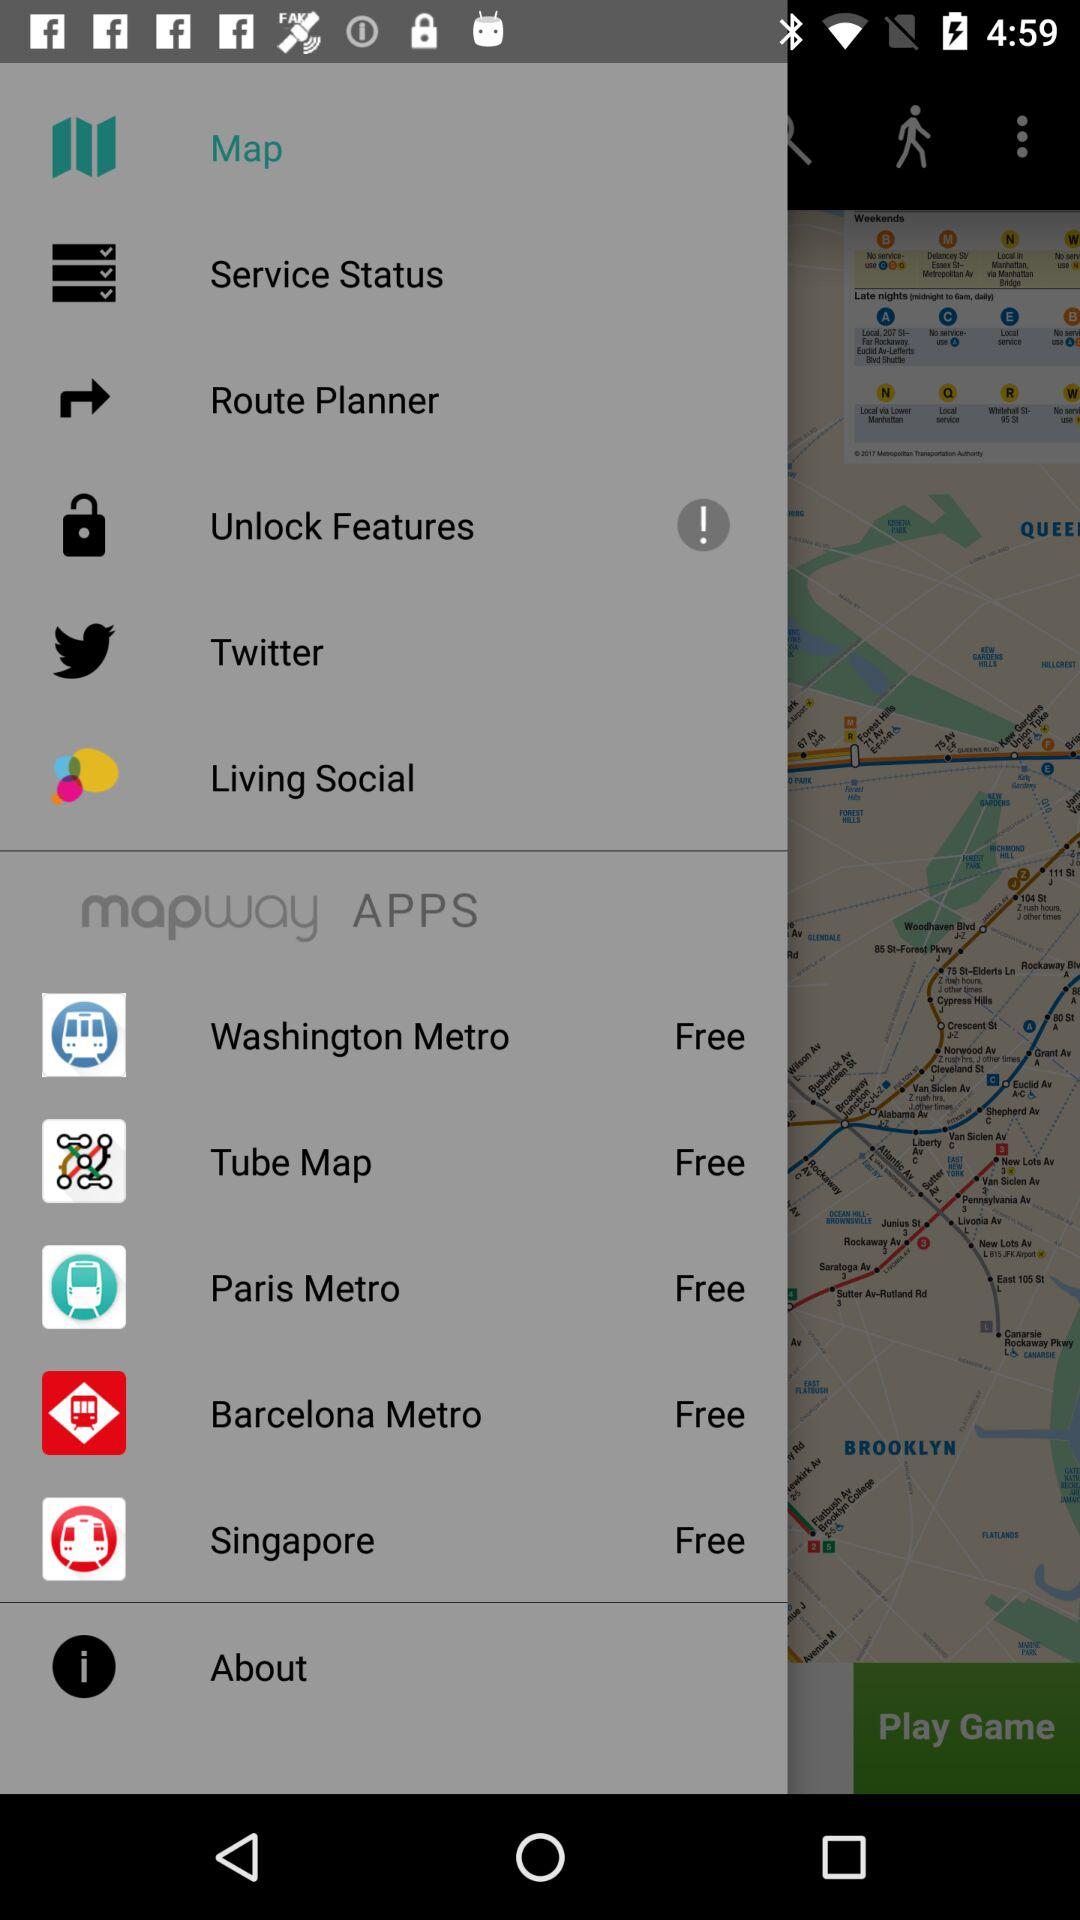How many apps are free?
Answer the question using a single word or phrase. 5 